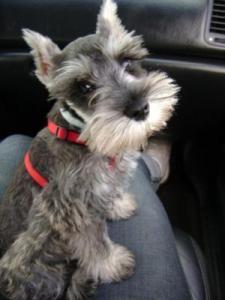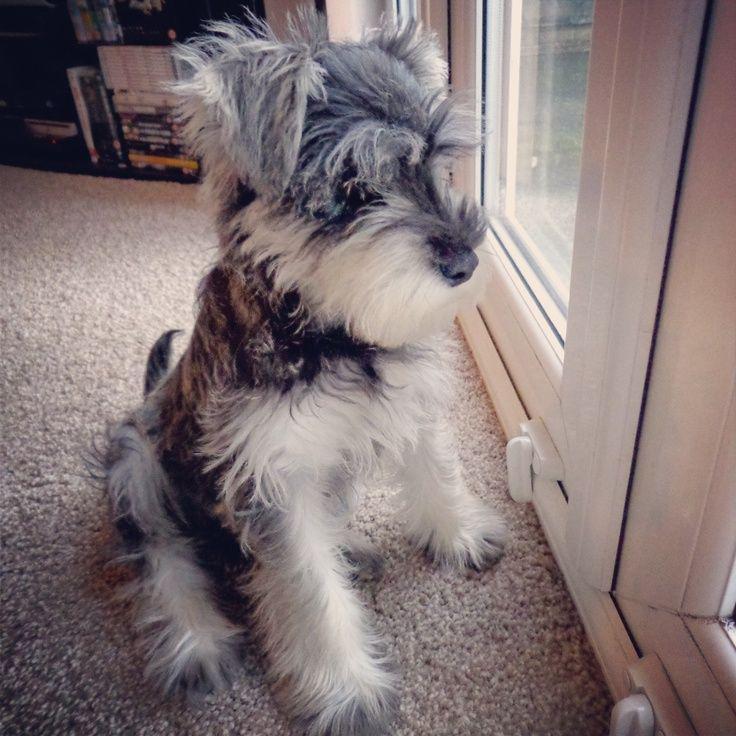The first image is the image on the left, the second image is the image on the right. For the images displayed, is the sentence "An image shows one schnauzer dog on a piece of upholstered furniture, next to a soft object." factually correct? Answer yes or no. No. The first image is the image on the left, the second image is the image on the right. Assess this claim about the two images: "The dog in the image on the left is wearing a collar.". Correct or not? Answer yes or no. Yes. 